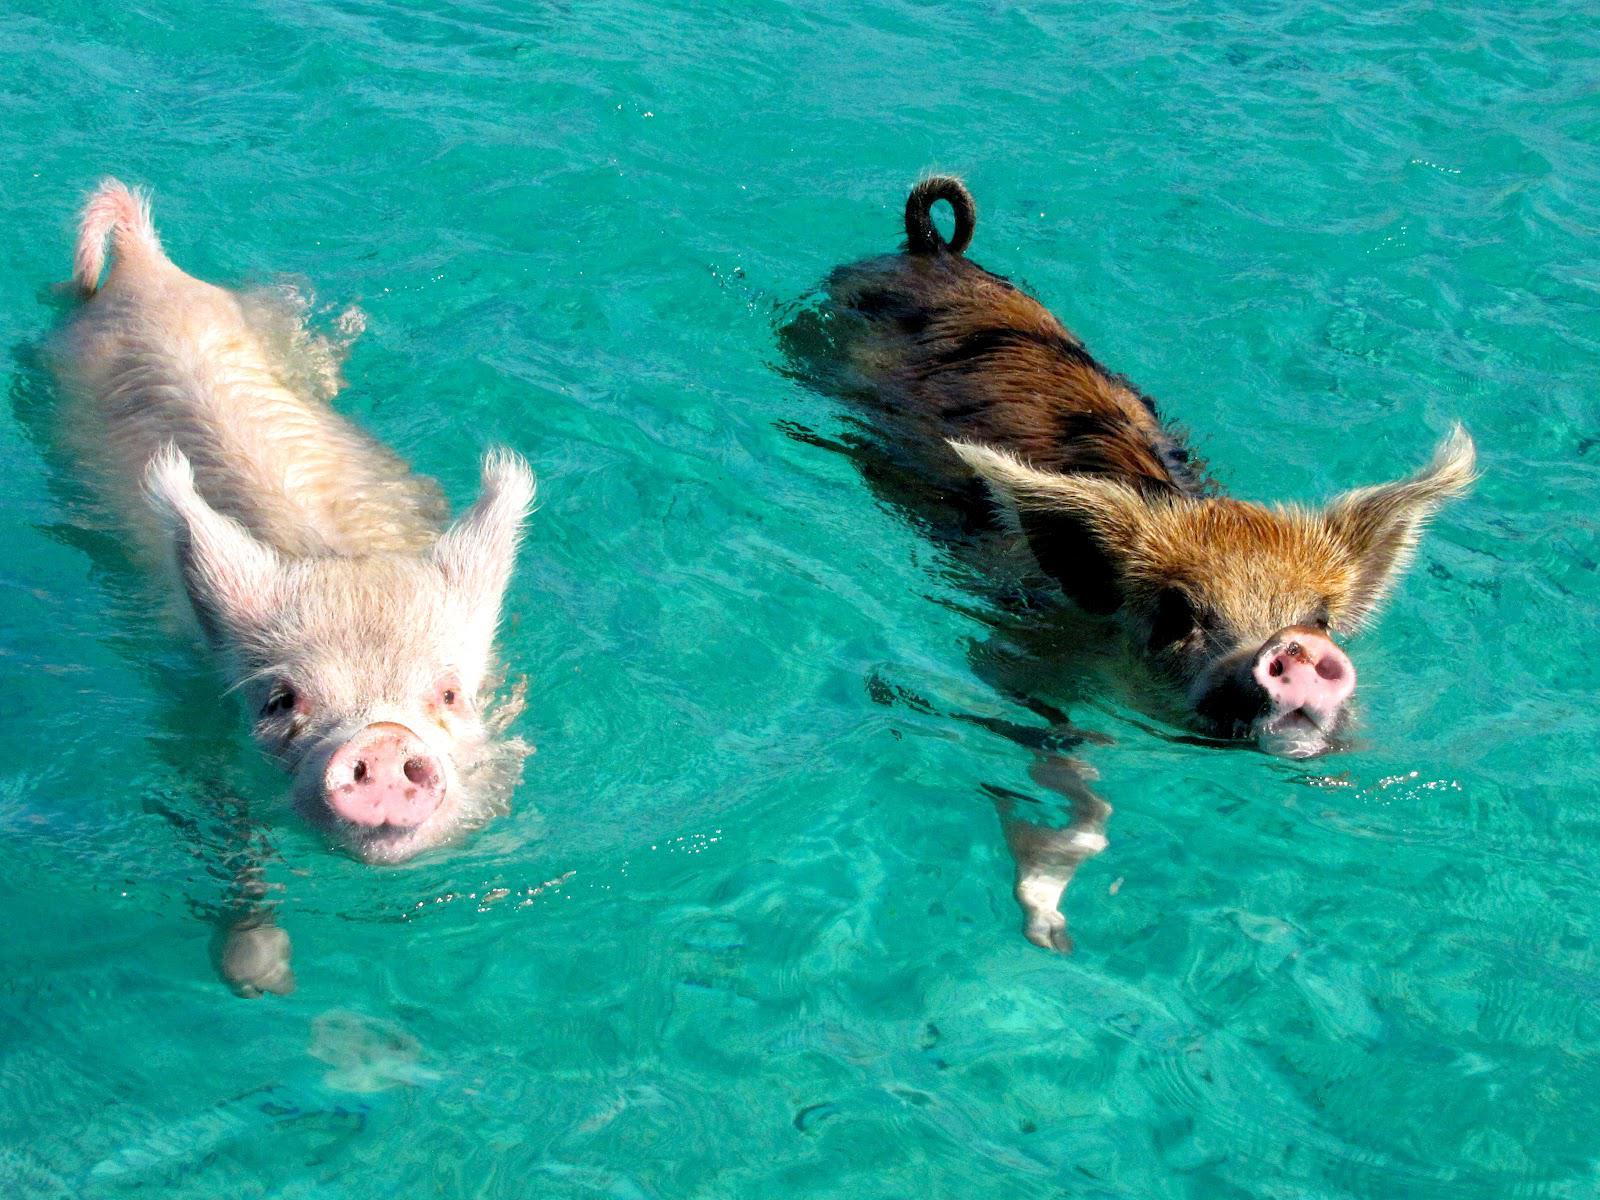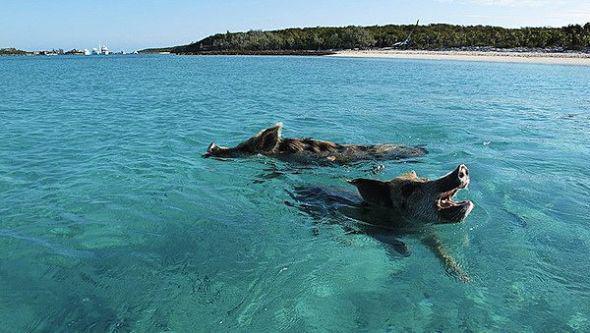The first image is the image on the left, the second image is the image on the right. For the images displayed, is the sentence "There are exactly four pigs swimming." factually correct? Answer yes or no. Yes. The first image is the image on the left, the second image is the image on the right. For the images displayed, is the sentence "Each image shows two pigs swimming in a body of water, and in at least one image, the pigs' snouts face opposite directions." factually correct? Answer yes or no. Yes. 